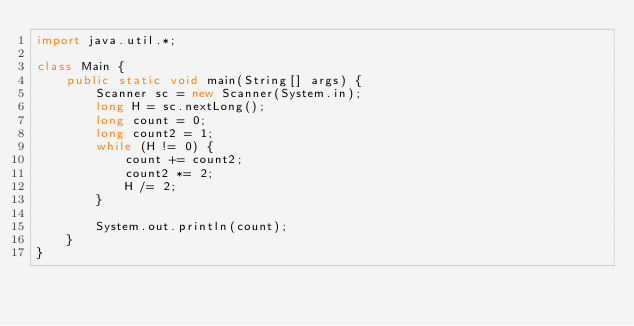Convert code to text. <code><loc_0><loc_0><loc_500><loc_500><_Java_>import java.util.*;

class Main {
    public static void main(String[] args) {
        Scanner sc = new Scanner(System.in);
        long H = sc.nextLong();
        long count = 0;
        long count2 = 1;
        while (H != 0) {
            count += count2;
            count2 *= 2;
            H /= 2;
        }

        System.out.println(count);
    }
}</code> 